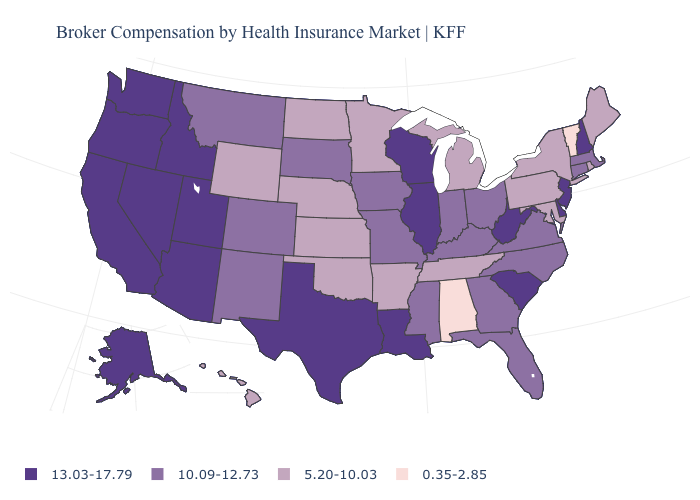Which states have the highest value in the USA?
Keep it brief. Alaska, Arizona, California, Delaware, Idaho, Illinois, Louisiana, Nevada, New Hampshire, New Jersey, Oregon, South Carolina, Texas, Utah, Washington, West Virginia, Wisconsin. Among the states that border New York , which have the highest value?
Keep it brief. New Jersey. Among the states that border New Jersey , does Pennsylvania have the highest value?
Short answer required. No. What is the value of Kansas?
Concise answer only. 5.20-10.03. Name the states that have a value in the range 13.03-17.79?
Concise answer only. Alaska, Arizona, California, Delaware, Idaho, Illinois, Louisiana, Nevada, New Hampshire, New Jersey, Oregon, South Carolina, Texas, Utah, Washington, West Virginia, Wisconsin. Does the first symbol in the legend represent the smallest category?
Quick response, please. No. What is the value of Montana?
Short answer required. 10.09-12.73. What is the value of Oklahoma?
Concise answer only. 5.20-10.03. Does the first symbol in the legend represent the smallest category?
Quick response, please. No. What is the highest value in states that border North Carolina?
Short answer required. 13.03-17.79. What is the lowest value in states that border Massachusetts?
Short answer required. 0.35-2.85. Which states have the lowest value in the USA?
Give a very brief answer. Alabama, Vermont. What is the highest value in the MidWest ?
Write a very short answer. 13.03-17.79. Name the states that have a value in the range 0.35-2.85?
Write a very short answer. Alabama, Vermont. 